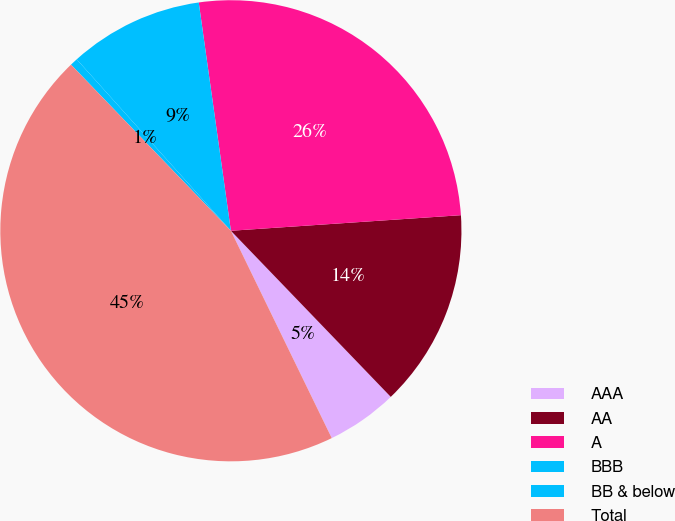Convert chart to OTSL. <chart><loc_0><loc_0><loc_500><loc_500><pie_chart><fcel>AAA<fcel>AA<fcel>A<fcel>BBB<fcel>BB & below<fcel>Total<nl><fcel>4.99%<fcel>13.88%<fcel>26.15%<fcel>9.43%<fcel>0.54%<fcel>45.01%<nl></chart> 